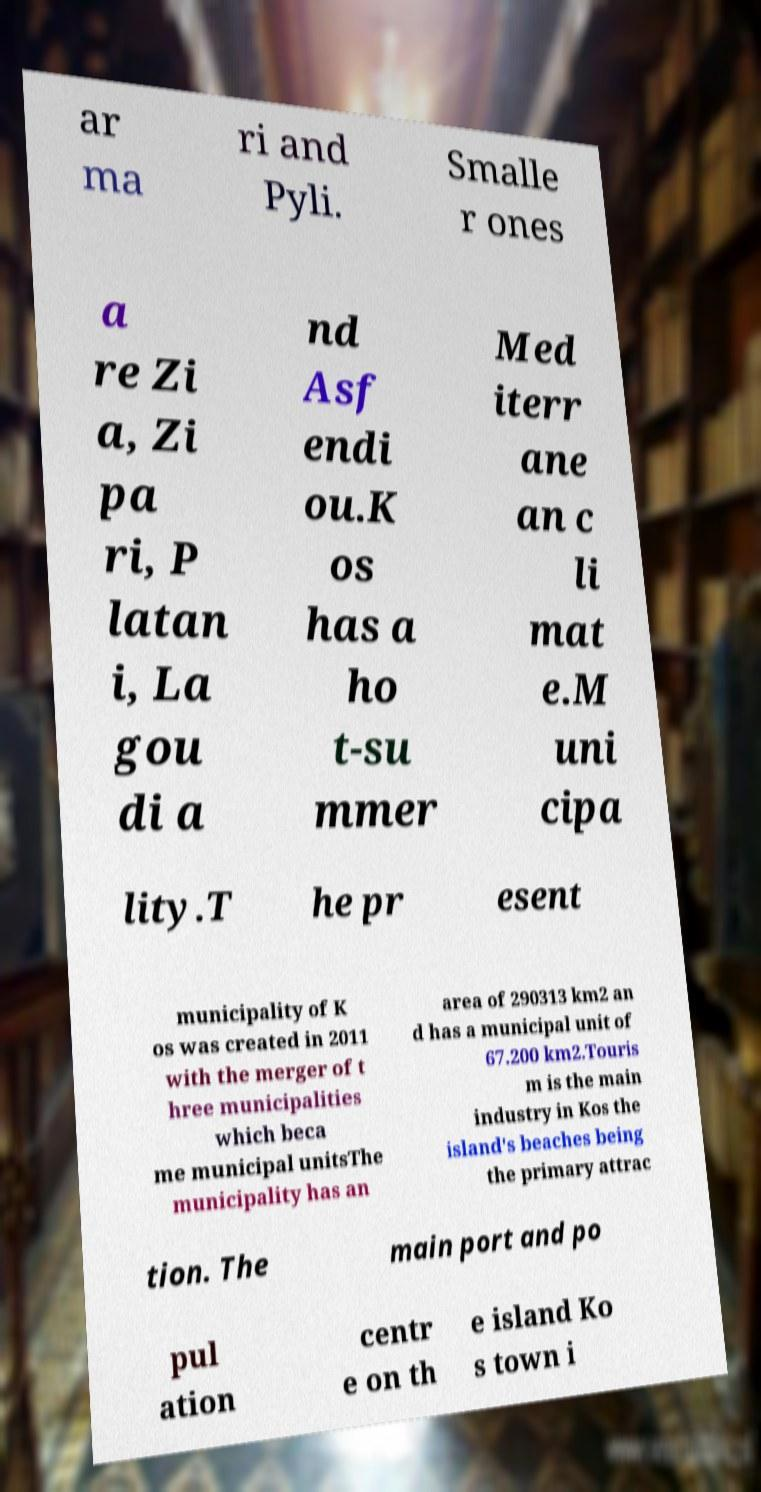Can you accurately transcribe the text from the provided image for me? ar ma ri and Pyli. Smalle r ones a re Zi a, Zi pa ri, P latan i, La gou di a nd Asf endi ou.K os has a ho t-su mmer Med iterr ane an c li mat e.M uni cipa lity.T he pr esent municipality of K os was created in 2011 with the merger of t hree municipalities which beca me municipal unitsThe municipality has an area of 290313 km2 an d has a municipal unit of 67.200 km2.Touris m is the main industry in Kos the island's beaches being the primary attrac tion. The main port and po pul ation centr e on th e island Ko s town i 